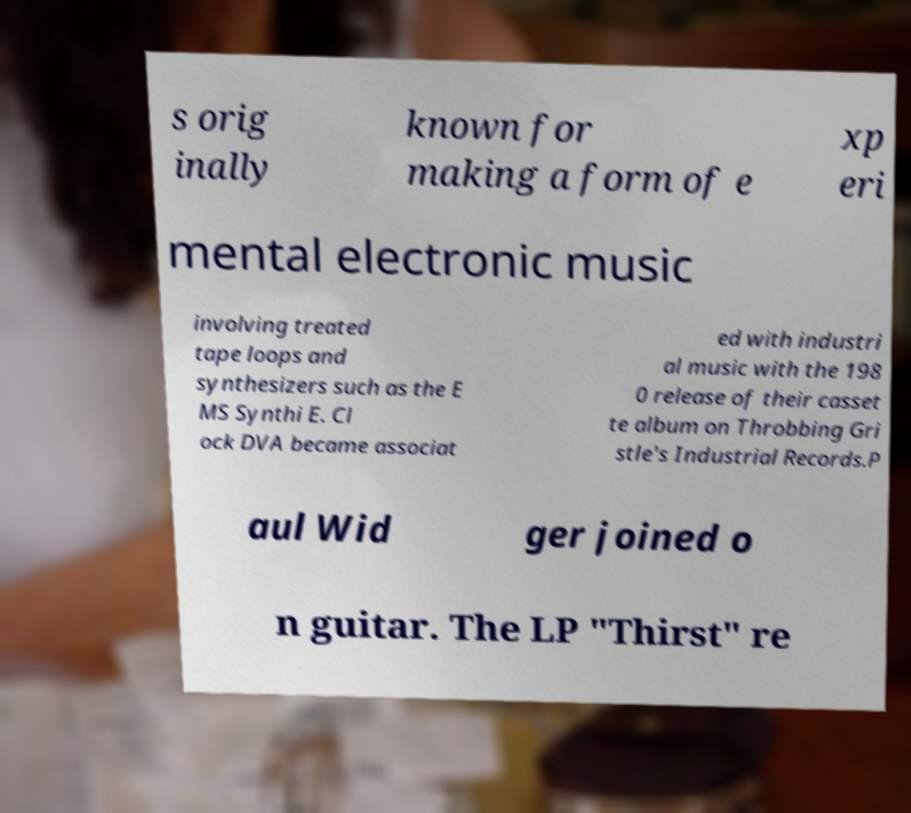There's text embedded in this image that I need extracted. Can you transcribe it verbatim? s orig inally known for making a form of e xp eri mental electronic music involving treated tape loops and synthesizers such as the E MS Synthi E. Cl ock DVA became associat ed with industri al music with the 198 0 release of their casset te album on Throbbing Gri stle's Industrial Records.P aul Wid ger joined o n guitar. The LP "Thirst" re 